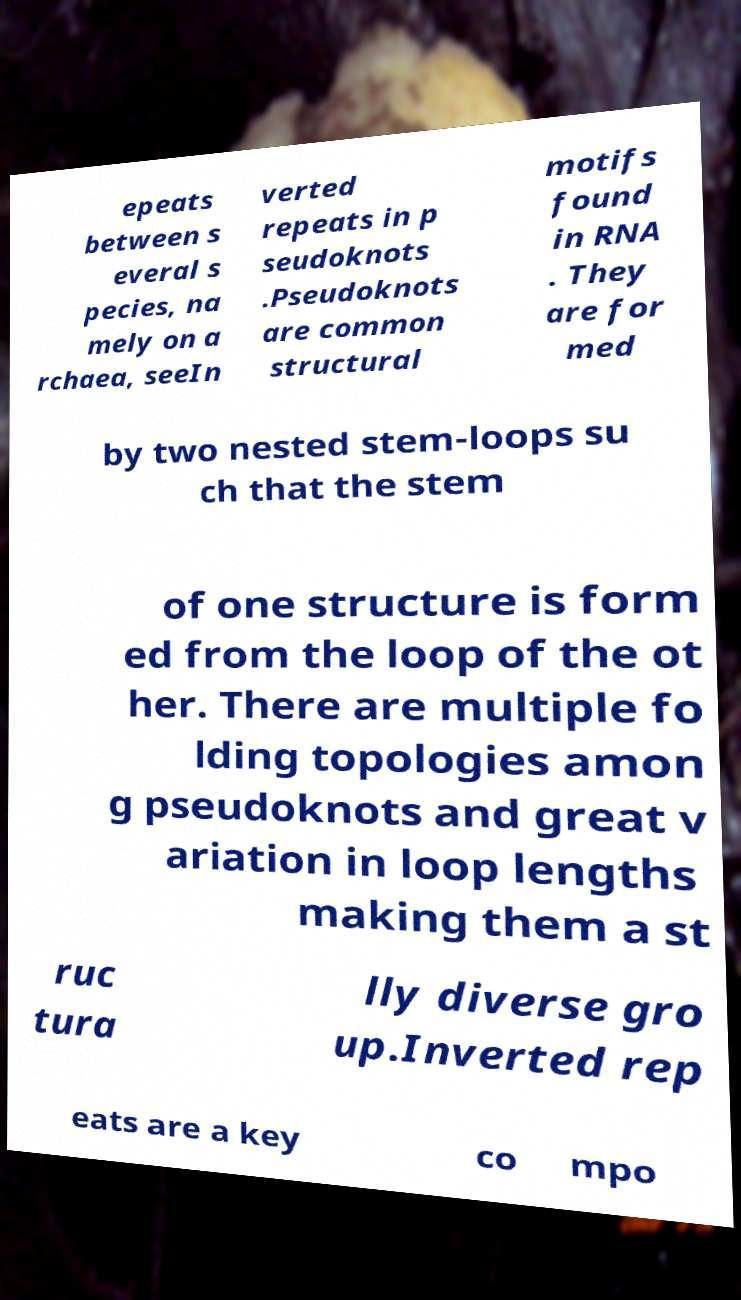Please read and relay the text visible in this image. What does it say? epeats between s everal s pecies, na mely on a rchaea, seeIn verted repeats in p seudoknots .Pseudoknots are common structural motifs found in RNA . They are for med by two nested stem-loops su ch that the stem of one structure is form ed from the loop of the ot her. There are multiple fo lding topologies amon g pseudoknots and great v ariation in loop lengths making them a st ruc tura lly diverse gro up.Inverted rep eats are a key co mpo 